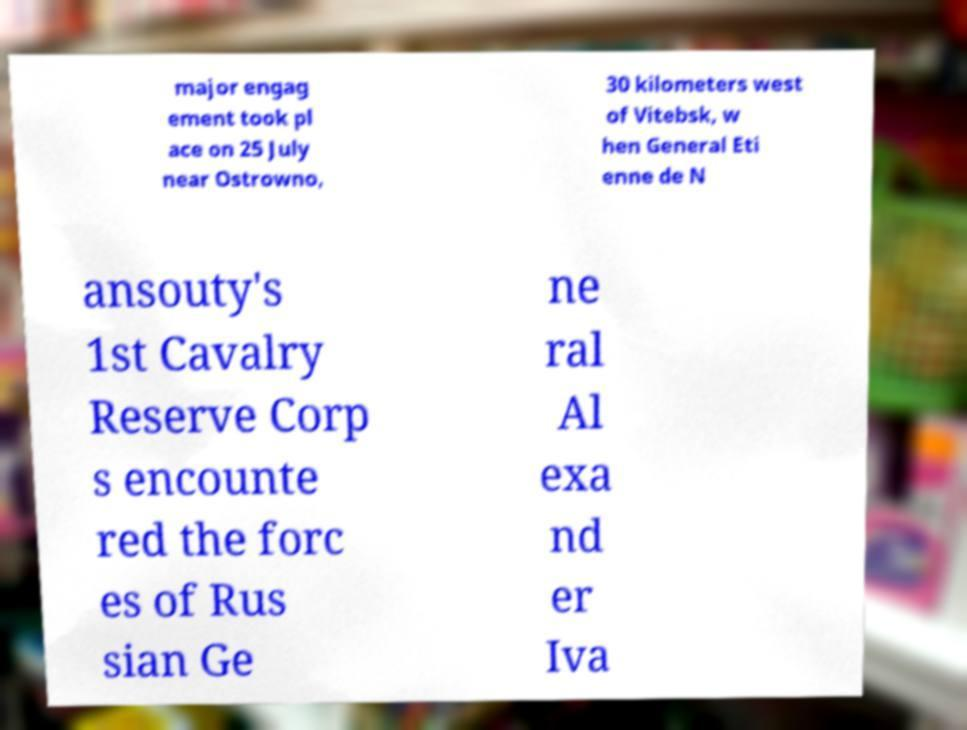Could you assist in decoding the text presented in this image and type it out clearly? major engag ement took pl ace on 25 July near Ostrowno, 30 kilometers west of Vitebsk, w hen General Eti enne de N ansouty's 1st Cavalry Reserve Corp s encounte red the forc es of Rus sian Ge ne ral Al exa nd er Iva 